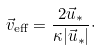<formula> <loc_0><loc_0><loc_500><loc_500>\vec { v } _ { \text {eff} } = \frac { 2 \vec { u } _ { * } } { \kappa | \vec { u } _ { * } | } \cdot</formula> 